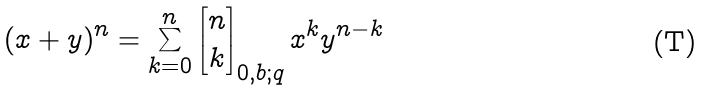Convert formula to latex. <formula><loc_0><loc_0><loc_500><loc_500>( x + y ) ^ { n } = \sum _ { k = 0 } ^ { n } \begin{bmatrix} n \\ k \end{bmatrix} _ { 0 , b ; q } x ^ { k } y ^ { n - k }</formula> 